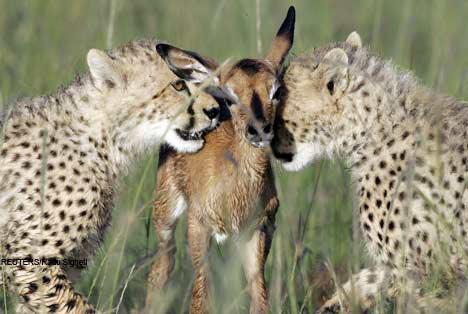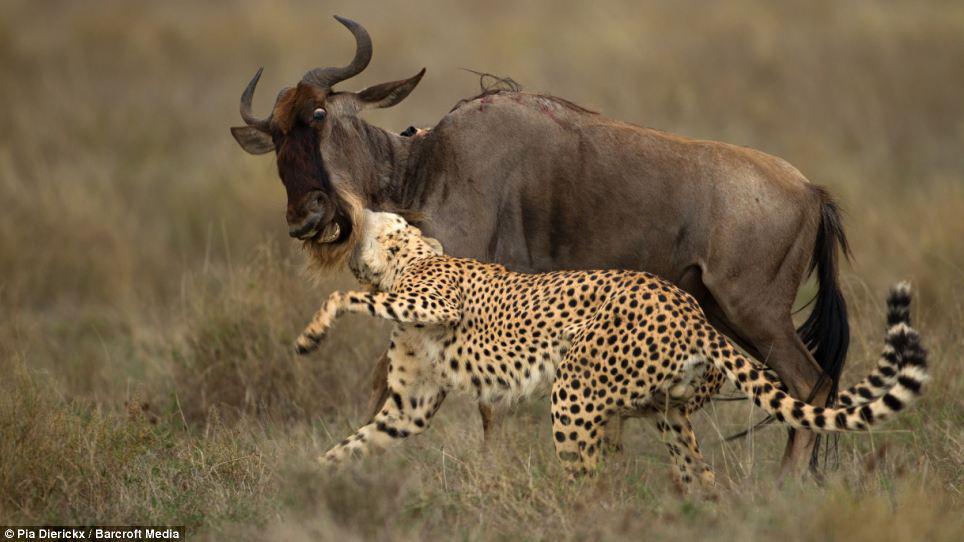The first image is the image on the left, the second image is the image on the right. Given the left and right images, does the statement "contains a picture of a cheetah carrying its food" hold true? Answer yes or no. No. The first image is the image on the left, the second image is the image on the right. For the images shown, is this caption "One image shows two cheetahs posing non-agressively with a small deerlike animal, and the other shows a cheetah with its prey grasped in its jaw." true? Answer yes or no. Yes. 